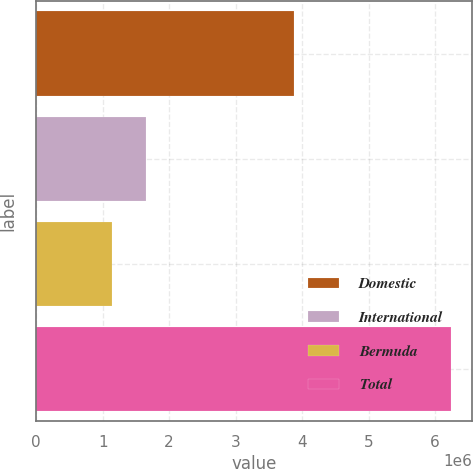Convert chart. <chart><loc_0><loc_0><loc_500><loc_500><bar_chart><fcel>Domestic<fcel>International<fcel>Bermuda<fcel>Total<nl><fcel>3.87598e+06<fcel>1.64964e+06<fcel>1.13908e+06<fcel>6.24466e+06<nl></chart> 